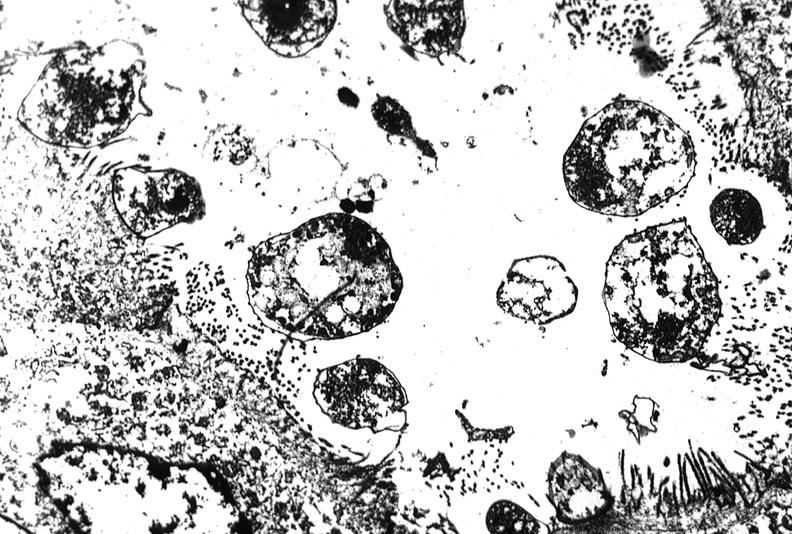what is present?
Answer the question using a single word or phrase. Gastrointestinal 